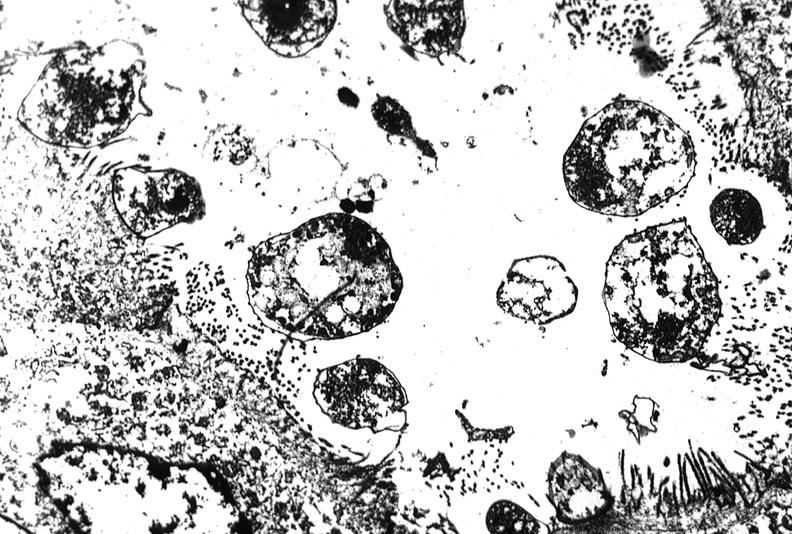what is present?
Answer the question using a single word or phrase. Gastrointestinal 